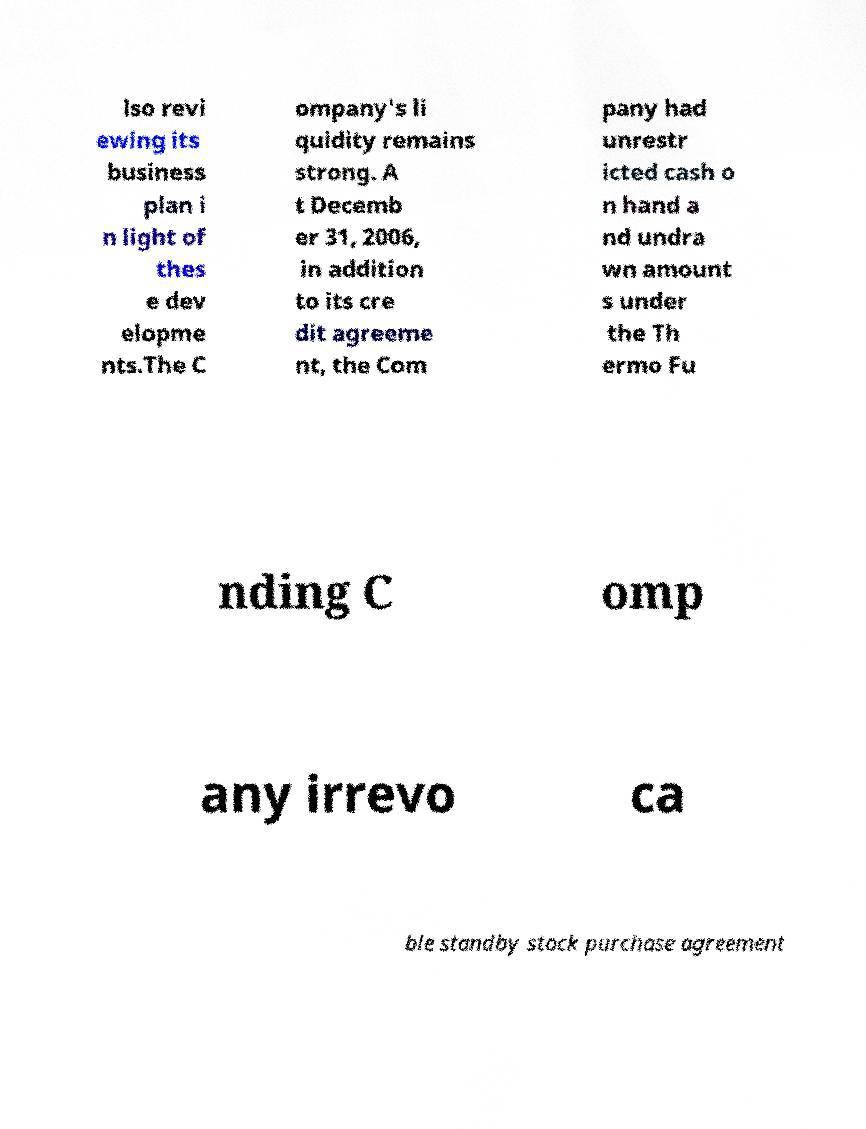For documentation purposes, I need the text within this image transcribed. Could you provide that? lso revi ewing its business plan i n light of thes e dev elopme nts.The C ompany's li quidity remains strong. A t Decemb er 31, 2006, in addition to its cre dit agreeme nt, the Com pany had unrestr icted cash o n hand a nd undra wn amount s under the Th ermo Fu nding C omp any irrevo ca ble standby stock purchase agreement 